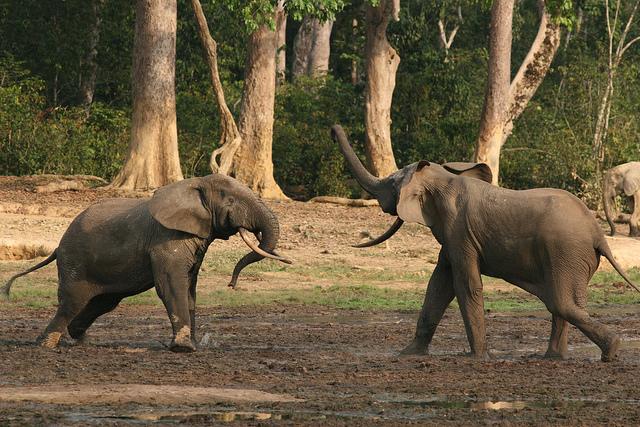Does the tree near the middle look like it has outstretched arms?
Be succinct. No. How many elephants are the main focus of the picture?
Keep it brief. 2. Are both elephants the same size?
Keep it brief. Yes. Are the elephants fighting?
Keep it brief. Yes. What kind of ground are the elephants on?
Keep it brief. Dirt. 